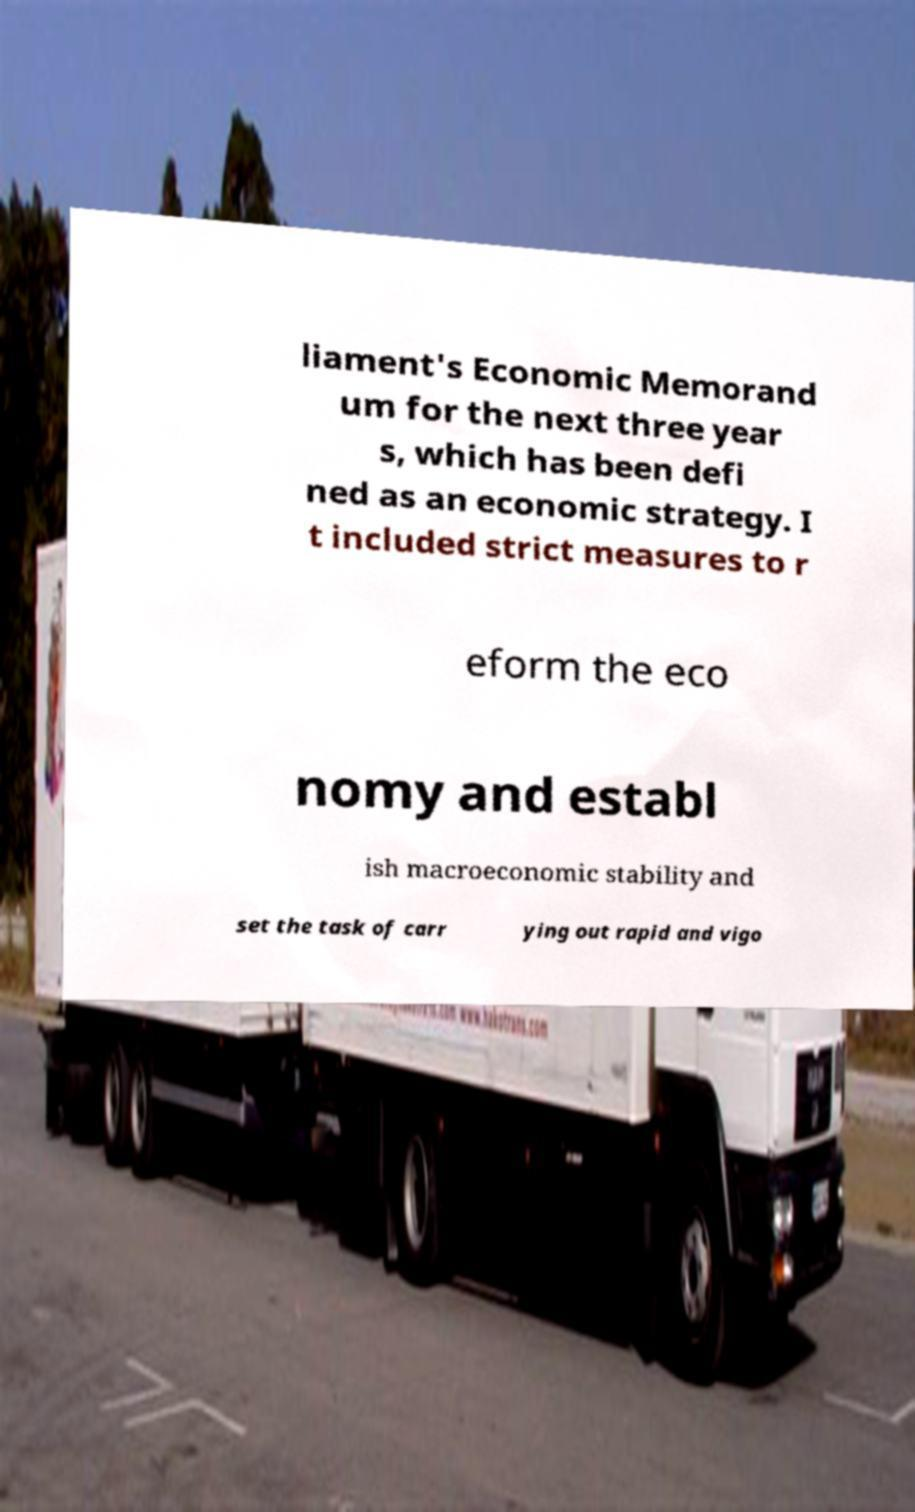I need the written content from this picture converted into text. Can you do that? liament's Economic Memorand um for the next three year s, which has been defi ned as an economic strategy. I t included strict measures to r eform the eco nomy and establ ish macroeconomic stability and set the task of carr ying out rapid and vigo 